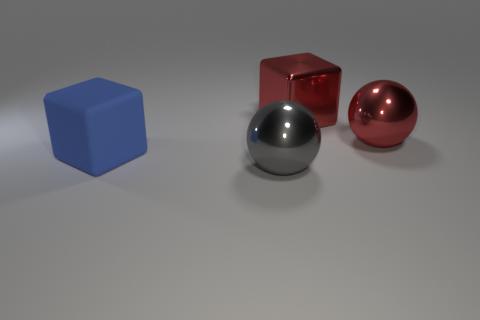Add 3 large gray shiny objects. How many objects exist? 7 Subtract all blue cubes. How many cubes are left? 1 Subtract 0 cyan balls. How many objects are left? 4 Subtract all gray cubes. Subtract all blue balls. How many cubes are left? 2 Subtract all metal things. Subtract all large red spheres. How many objects are left? 0 Add 1 blue things. How many blue things are left? 2 Add 1 large metal blocks. How many large metal blocks exist? 2 